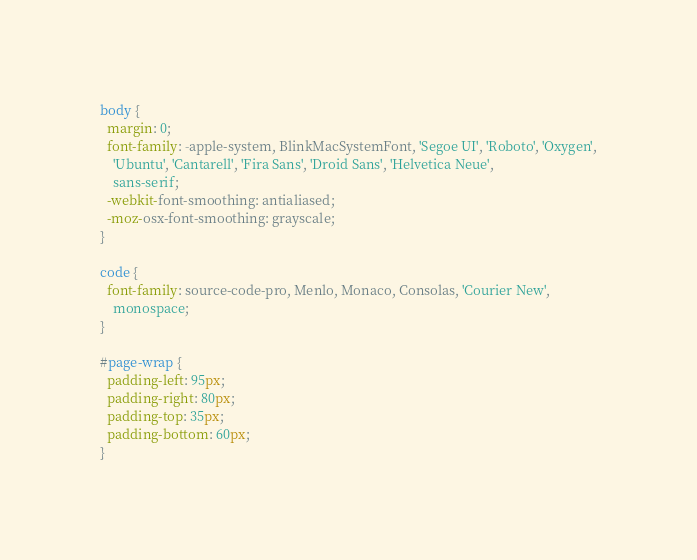<code> <loc_0><loc_0><loc_500><loc_500><_CSS_>body {
  margin: 0;
  font-family: -apple-system, BlinkMacSystemFont, 'Segoe UI', 'Roboto', 'Oxygen',
    'Ubuntu', 'Cantarell', 'Fira Sans', 'Droid Sans', 'Helvetica Neue',
    sans-serif;
  -webkit-font-smoothing: antialiased;
  -moz-osx-font-smoothing: grayscale;
}

code {
  font-family: source-code-pro, Menlo, Monaco, Consolas, 'Courier New',
    monospace;
}

#page-wrap {
  padding-left: 95px;
  padding-right: 80px;
  padding-top: 35px;
  padding-bottom: 60px;
}
</code> 